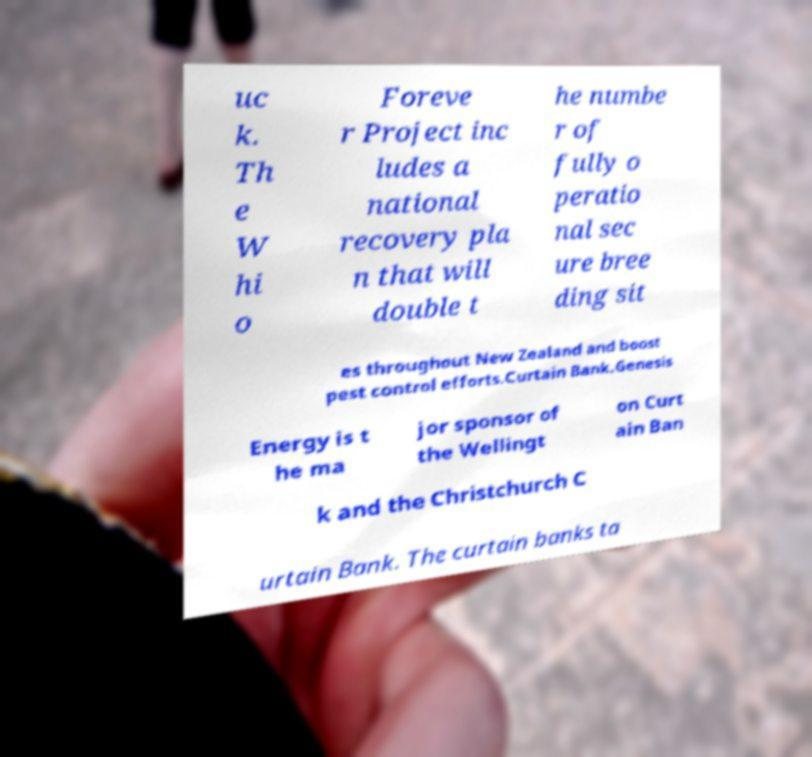Can you accurately transcribe the text from the provided image for me? uc k. Th e W hi o Foreve r Project inc ludes a national recovery pla n that will double t he numbe r of fully o peratio nal sec ure bree ding sit es throughout New Zealand and boost pest control efforts.Curtain Bank.Genesis Energy is t he ma jor sponsor of the Wellingt on Curt ain Ban k and the Christchurch C urtain Bank. The curtain banks ta 